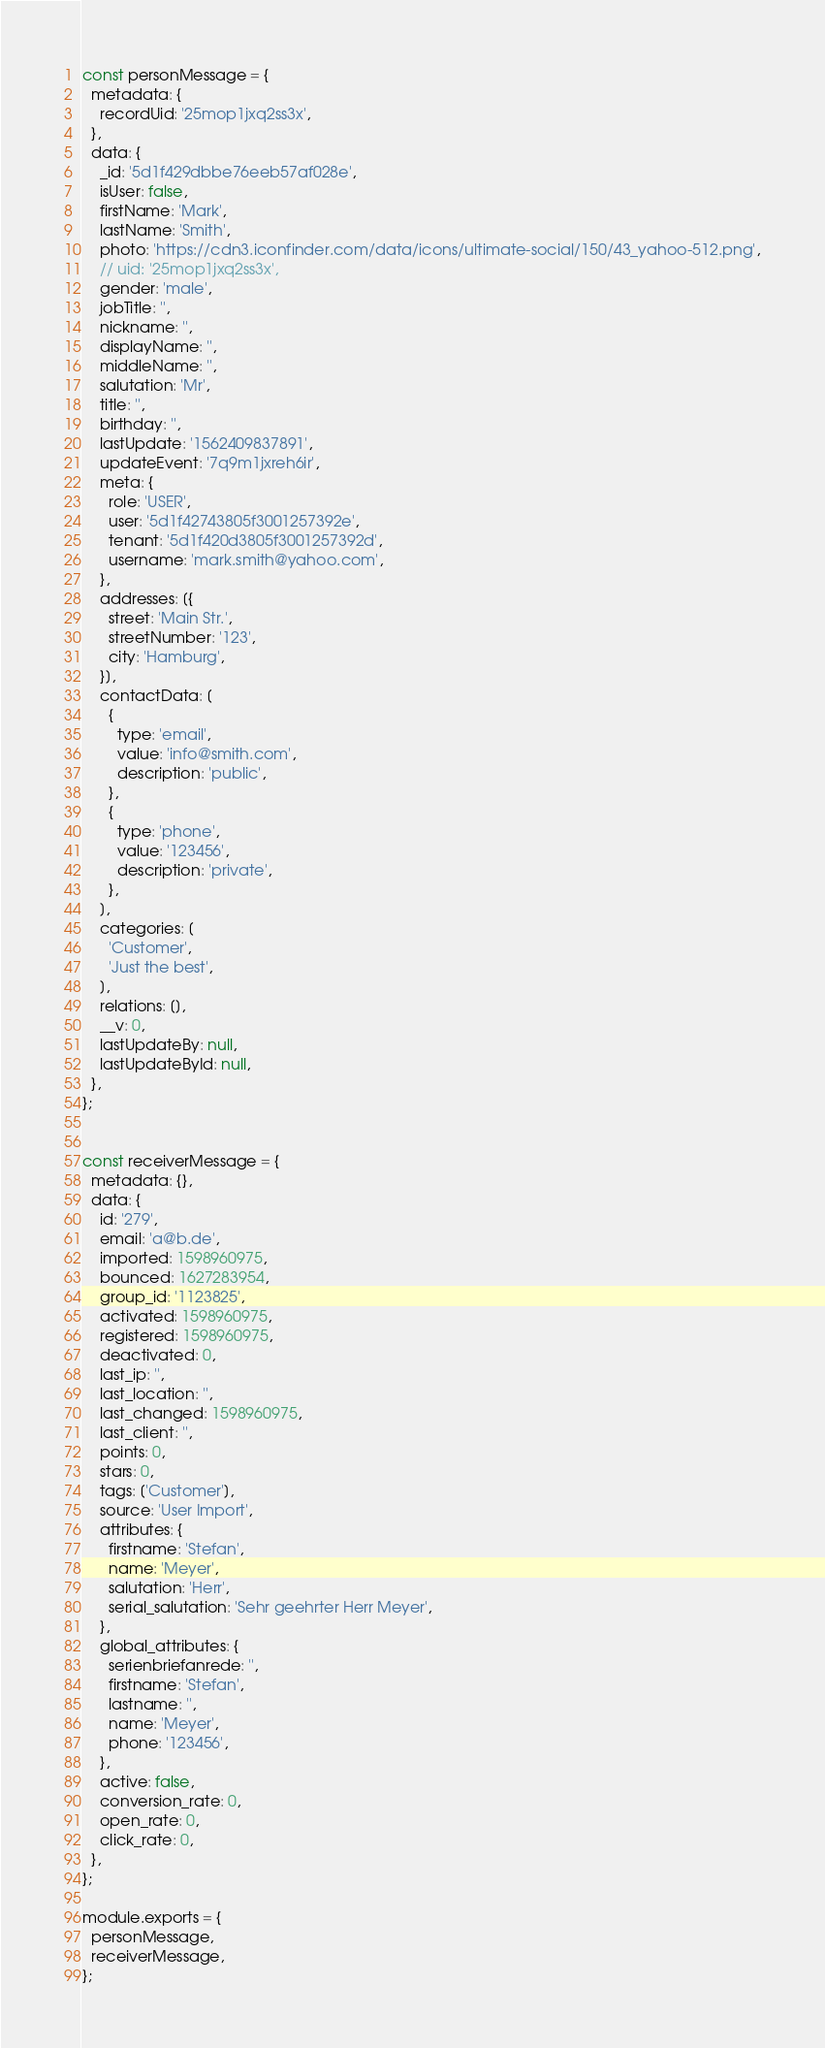Convert code to text. <code><loc_0><loc_0><loc_500><loc_500><_JavaScript_>
const personMessage = {
  metadata: {
    recordUid: '25mop1jxq2ss3x',
  },
  data: {
    _id: '5d1f429dbbe76eeb57af028e',
    isUser: false,
    firstName: 'Mark',
    lastName: 'Smith',
    photo: 'https://cdn3.iconfinder.com/data/icons/ultimate-social/150/43_yahoo-512.png',
    // uid: '25mop1jxq2ss3x',
    gender: 'male',
    jobTitle: '',
    nickname: '',
    displayName: '',
    middleName: '',
    salutation: 'Mr',
    title: '',
    birthday: '',
    lastUpdate: '1562409837891',
    updateEvent: '7q9m1jxreh6ir',
    meta: {
      role: 'USER',
      user: '5d1f42743805f3001257392e',
      tenant: '5d1f420d3805f3001257392d',
      username: 'mark.smith@yahoo.com',
    },
    addresses: [{
      street: 'Main Str.',
      streetNumber: '123',
      city: 'Hamburg',
    }],
    contactData: [
      {
        type: 'email',
        value: 'info@smith.com',
        description: 'public',
      },
      {
        type: 'phone',
        value: '123456',
        description: 'private',
      },
    ],
    categories: [
      'Customer',
      'Just the best',
    ],
    relations: [],
    __v: 0,
    lastUpdateBy: null,
    lastUpdateById: null,
  },
};


const receiverMessage = {
  metadata: {},
  data: {
    id: '279',
    email: 'a@b.de',
    imported: 1598960975,
    bounced: 1627283954,
    group_id: '1123825',
    activated: 1598960975,
    registered: 1598960975,
    deactivated: 0,
    last_ip: '',
    last_location: '',
    last_changed: 1598960975,
    last_client: '',
    points: 0,
    stars: 0,
    tags: ['Customer'],
    source: 'User Import',
    attributes: {
      firstname: 'Stefan',
      name: 'Meyer',
      salutation: 'Herr',
      serial_salutation: 'Sehr geehrter Herr Meyer',
    },
    global_attributes: {
      serienbriefanrede: '',
      firstname: 'Stefan',
      lastname: '',
      name: 'Meyer',
      phone: '123456',
    },
    active: false,
    conversion_rate: 0,
    open_rate: 0,
    click_rate: 0,
  },
};

module.exports = {
  personMessage,
  receiverMessage,
};
</code> 